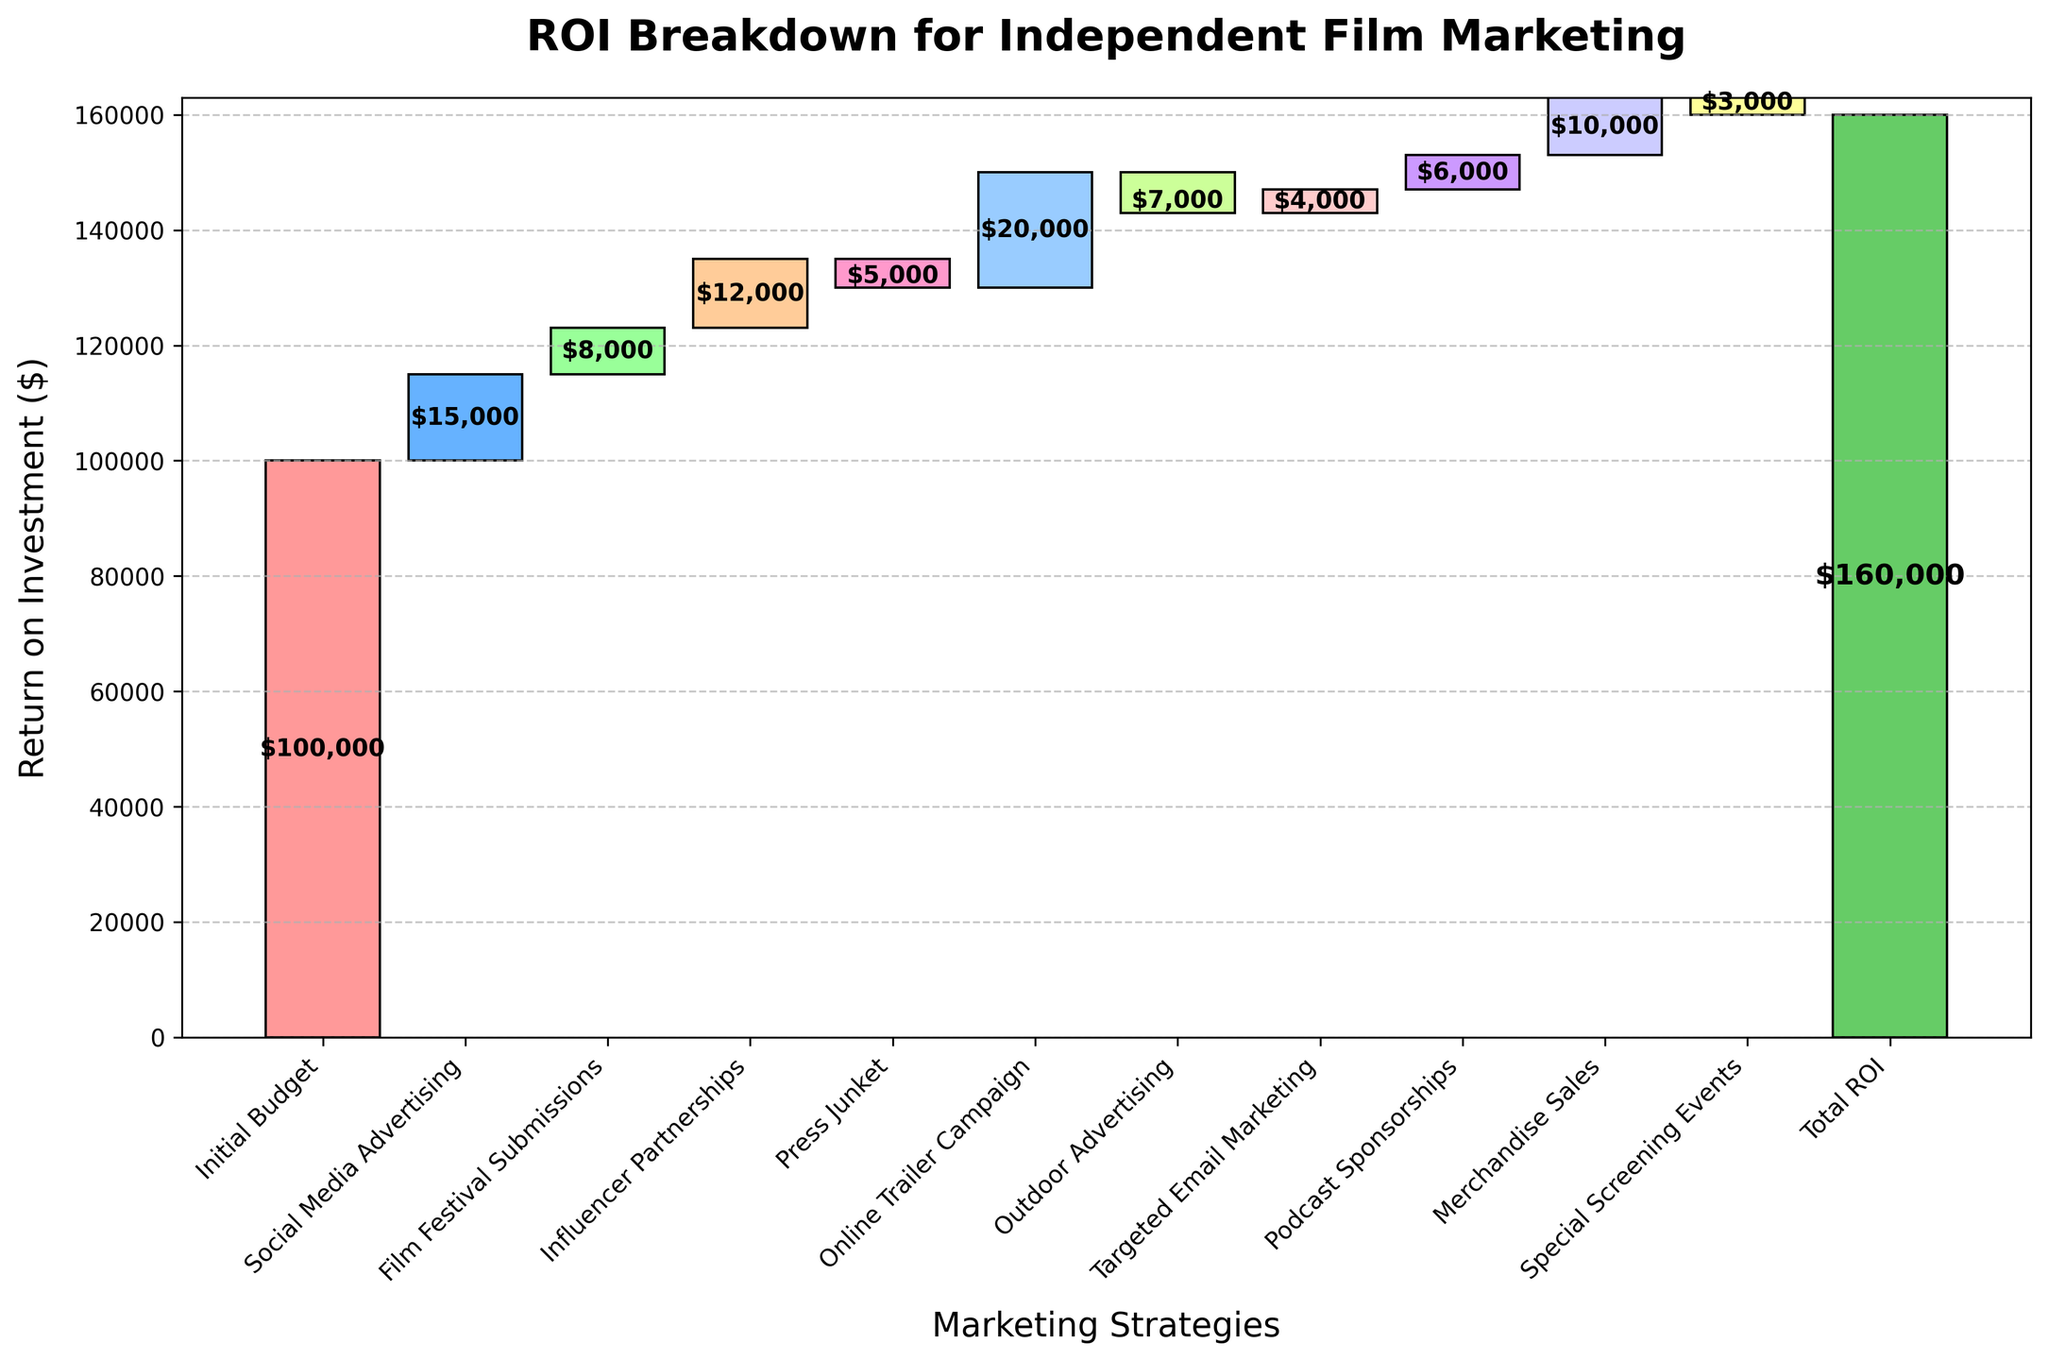What is the title of the figure? The title of the figure is displayed prominently at the top in bold. It reads "ROI Breakdown for Independent Film Marketing."
Answer: ROI Breakdown for Independent Film Marketing What is the total ROI from the marketing strategies? The total ROI is indicated by the tallest bar on the right side of the chart and is labeled accordingly. This bar has a value of $160,000.
Answer: $160,000 How much was invested in Social Media Advertising? The height of the bar for "Social Media Advertising," along with its value label, shows the amount invested. It is $15,000.
Answer: $15,000 Which marketing strategy resulted in the highest return? Comparing all the positive values, the "Online Trailer Campaign" shows the highest return with $20,000.
Answer: Online Trailer Campaign What is the cumulative value after the "Influencer Partnerships" step? Summing the initial budget of $100,000, Social Media Advertising cost of $15,000, Film Festival Submissions cost of $8,000, and Influencer Partnerships cost of $12,000 results in $135,000.
Answer: $135,000 How much did the "Press Junket" decrease the overall ROI? The "Press Junket" has a negative value indicated by the downward bar, showing a decrease of $5,000.
Answer: $5,000 How do "Special Screening Events" compare to "Podcast Sponsorships" in terms of ROI? "Special Screening Events" have a negative ROI of $3,000, while "Podcast Sponsorships" add a positive ROI of $6,000, resulting in "Podcast Sponsorships" providing a better return by $9,000.
Answer: Podcast Sponsorships are better by $9,000 What is the cumulative ROI after "Outdoor Advertising"? Starting with the initial budget of $100,000, adding Social Media Advertising $15,000, subtracting Film Festival Submissions $8,000, adding Influencer Partnerships $12,000, subtracting Press Junket $5,000, and subtracting Outdoor Advertising $7,000 results in a cumulative ROI of $107,000.
Answer: $107,000 Which marketing strategy led to the lowest return, and what was the amount? "Outdoor Advertising" had the lowest return with a negative amount of $7,000, indicated by the shortest downward bar.
Answer: Outdoor Advertising, -$7,000 